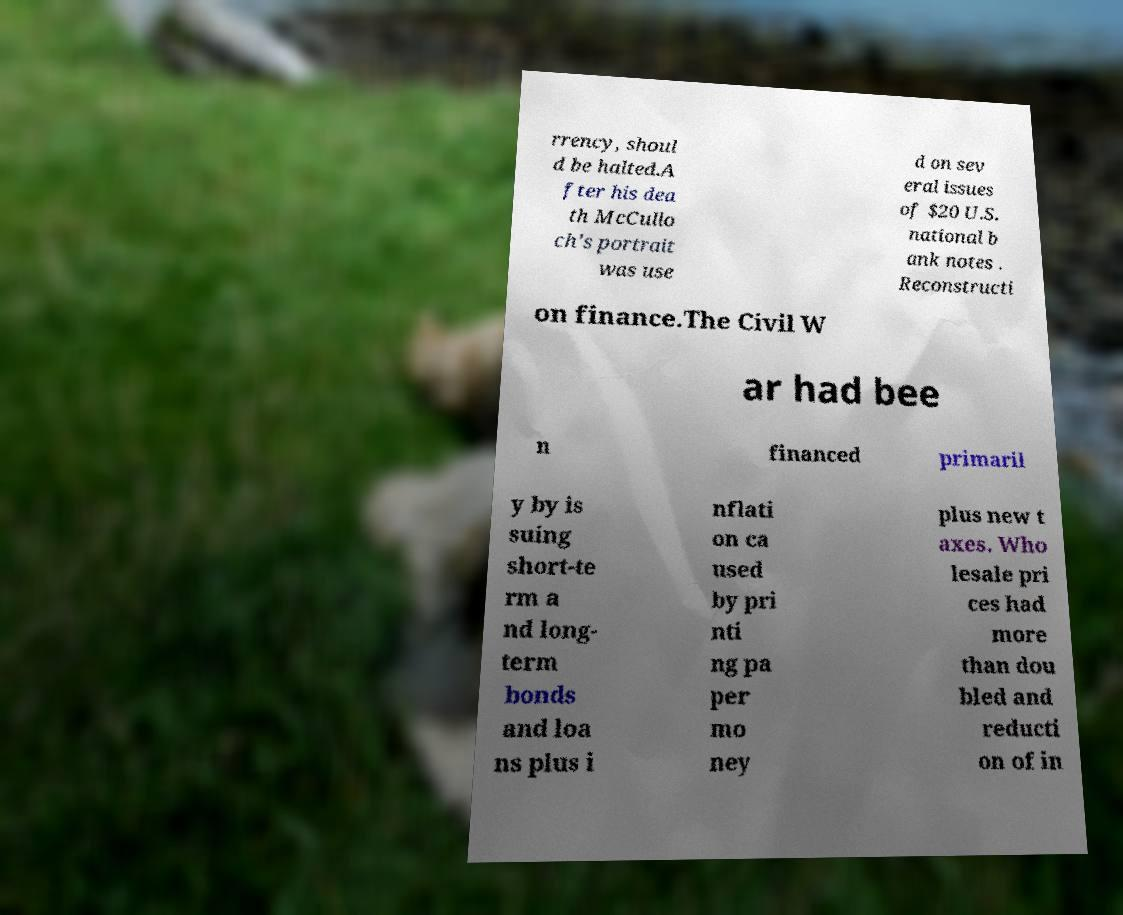Could you extract and type out the text from this image? rrency, shoul d be halted.A fter his dea th McCullo ch's portrait was use d on sev eral issues of $20 U.S. national b ank notes . Reconstructi on finance.The Civil W ar had bee n financed primaril y by is suing short-te rm a nd long- term bonds and loa ns plus i nflati on ca used by pri nti ng pa per mo ney plus new t axes. Who lesale pri ces had more than dou bled and reducti on of in 